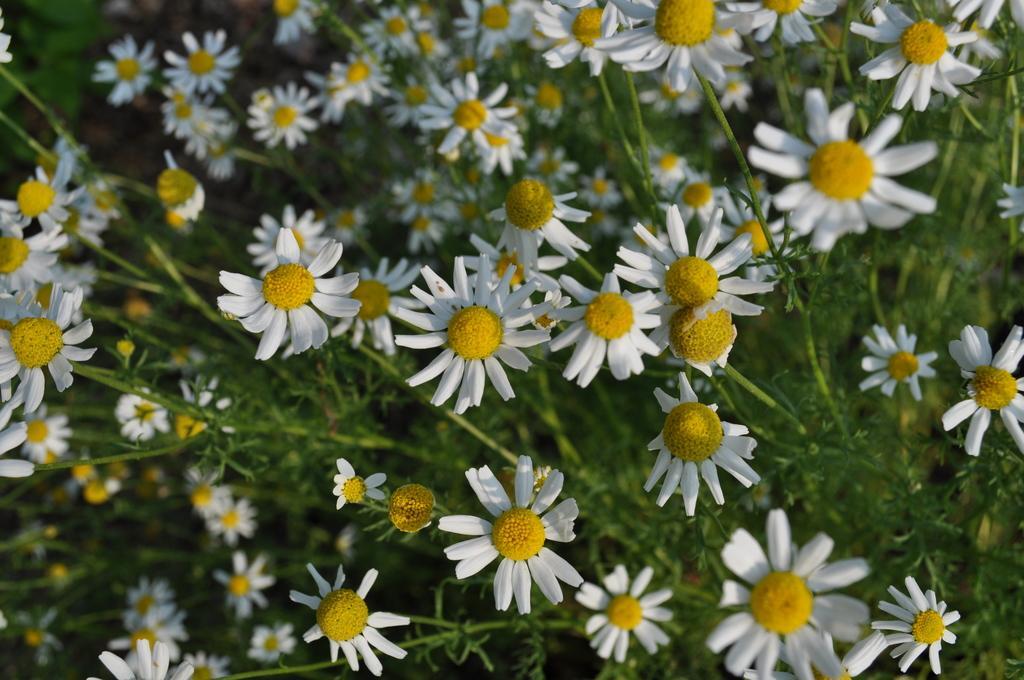Please provide a concise description of this image. In this picture we can see a group of flowers and in the background we can see plants and it is blurry. 